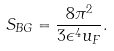Convert formula to latex. <formula><loc_0><loc_0><loc_500><loc_500>S _ { B G } = \frac { 8 \pi ^ { 2 } } { 3 \epsilon ^ { 4 } u _ { F } } .</formula> 